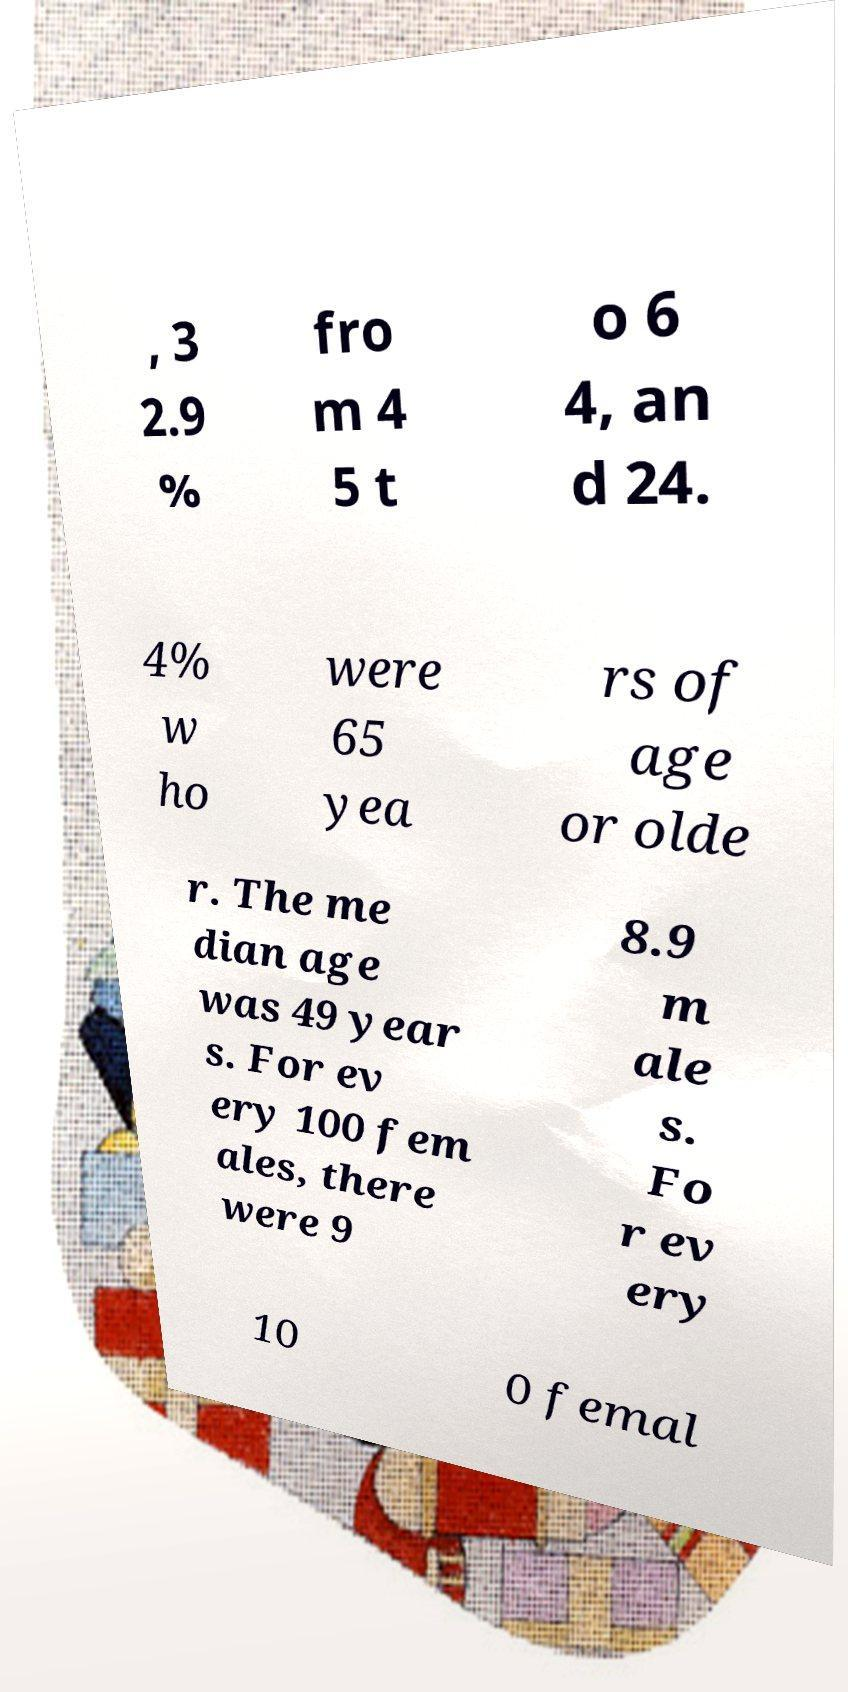There's text embedded in this image that I need extracted. Can you transcribe it verbatim? , 3 2.9 % fro m 4 5 t o 6 4, an d 24. 4% w ho were 65 yea rs of age or olde r. The me dian age was 49 year s. For ev ery 100 fem ales, there were 9 8.9 m ale s. Fo r ev ery 10 0 femal 